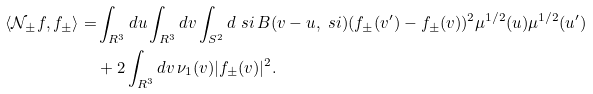<formula> <loc_0><loc_0><loc_500><loc_500>\langle \mathcal { N } _ { \pm } f , f _ { \pm } \rangle = & \int _ { { R } ^ { 3 } } d u \int _ { { R } ^ { 3 } } d v \int _ { { S } ^ { 2 } } d \ s i \, B ( v - u , \ s i ) ( f _ { \pm } ( v ^ { \prime } ) - f _ { \pm } ( v ) ) ^ { 2 } \mu ^ { 1 / 2 } ( u ) \mu ^ { 1 / 2 } ( u ^ { \prime } ) \\ & + 2 \int _ { { R } ^ { 3 } } d v \, \nu _ { 1 } ( v ) | f _ { \pm } ( v ) | ^ { 2 } .</formula> 